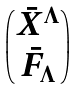<formula> <loc_0><loc_0><loc_500><loc_500>\begin{pmatrix} \bar { X } ^ { \Lambda } \\ \bar { F } _ { \Lambda } \end{pmatrix}</formula> 